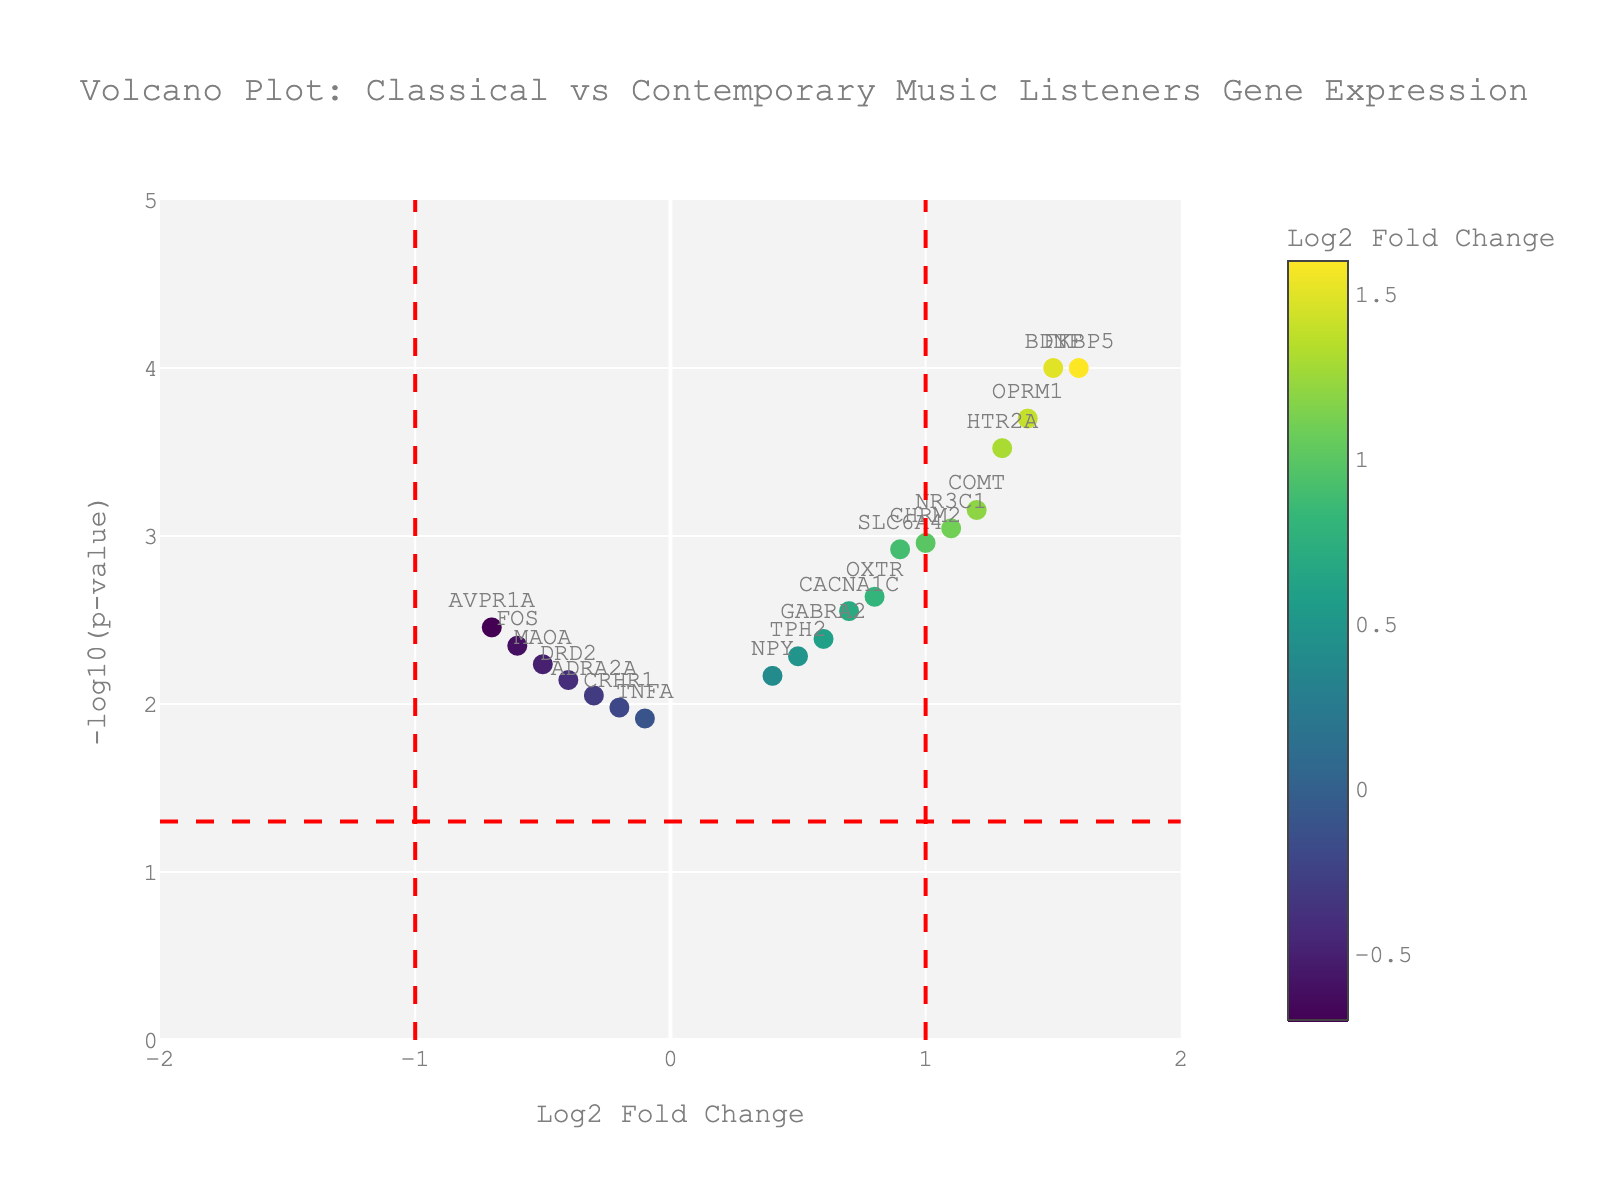How many genes have a significant p-value below 0.05? Genes with significant p-values are those above the red horizontal line. There are 20 genes plotted, and all are above this line, indicating they have p-values below 0.05.
Answer: 20 Which gene has the highest Log2 Fold Change? The Log2 Fold Change is represented on the x-axis, and the gene with the highest positive value on this axis is FKBP5.
Answer: FKBP5 What is the approximate p-value for the gene with the lowest Log2 Fold Change? The lowest Log2 Fold Change is near -0.7 (AVPR1A), and its corresponding -log10(p-value) is slightly above 3, indicating a p-value around 0.0022.
Answer: ~0.0022 How many genes have a Log2 Fold Change greater than 1? Genes with Log2 Fold Change greater than 1 are to the right of the vertical red line at x=1. These genes are BDNF, COMT, NR3C1, HTR2A, OPRM1, and FKBP5, totaling 6.
Answer: 6 What is the Log2 Fold Change and p-value for the gene FOS? By looking for the text "FOS" on the plot, we can see that FOS has a Log2 Fold Change around -0.6 and a -log10(p-value) around 2.7, meaning its p-value is about 0.0045.
Answer: -0.6, 0.0045 Which gene is closest to the point Log2 Fold Change of 0 and highest -log10(p-value)? The gene closest to Log2 Fold Change of 0 with the highest -log10(p-value) is likely NPY, positioned near the x-axis value of 0 and highest y-axis value.
Answer: NPY What is the significance threshold indicated in the plot? The significance threshold is indicated by the horizontal red dashed line, which is at -log10(p-value) = 1.3, corresponding to p-value = 0.05.
Answer: p-value = 0.05 Which gene has the highest -log10(p-value)? The highest -log10(p-value) indicates the most significant gene, seen as the tallest point in the plot which is BDNF with a -log10(p-value) of approximately 4.
Answer: BDNF Are there more genes with a positive or negative Log2 Fold Change? By counting the genes on each side of the y-axis, there are more genes with a positive Log2 Fold Change (right side). There are 12 on the positive side and 8 on the negative side.
Answer: More positive 